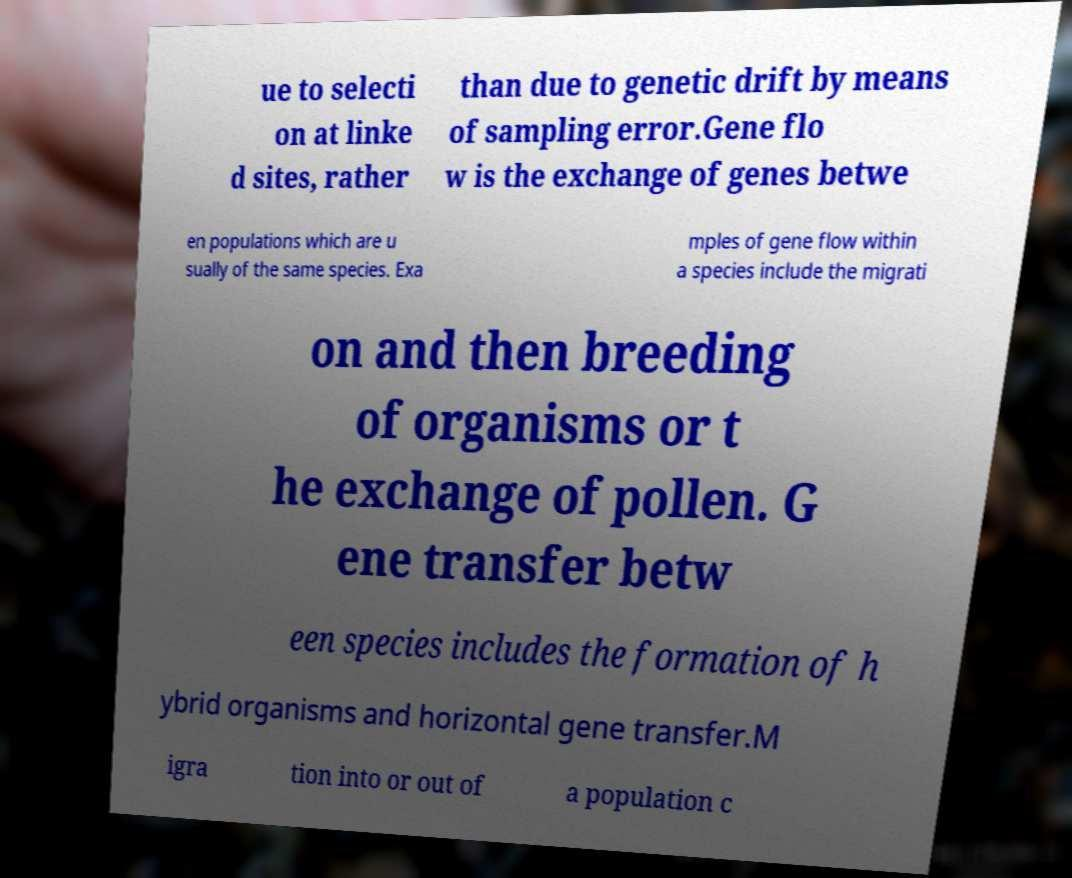What messages or text are displayed in this image? I need them in a readable, typed format. ue to selecti on at linke d sites, rather than due to genetic drift by means of sampling error.Gene flo w is the exchange of genes betwe en populations which are u sually of the same species. Exa mples of gene flow within a species include the migrati on and then breeding of organisms or t he exchange of pollen. G ene transfer betw een species includes the formation of h ybrid organisms and horizontal gene transfer.M igra tion into or out of a population c 